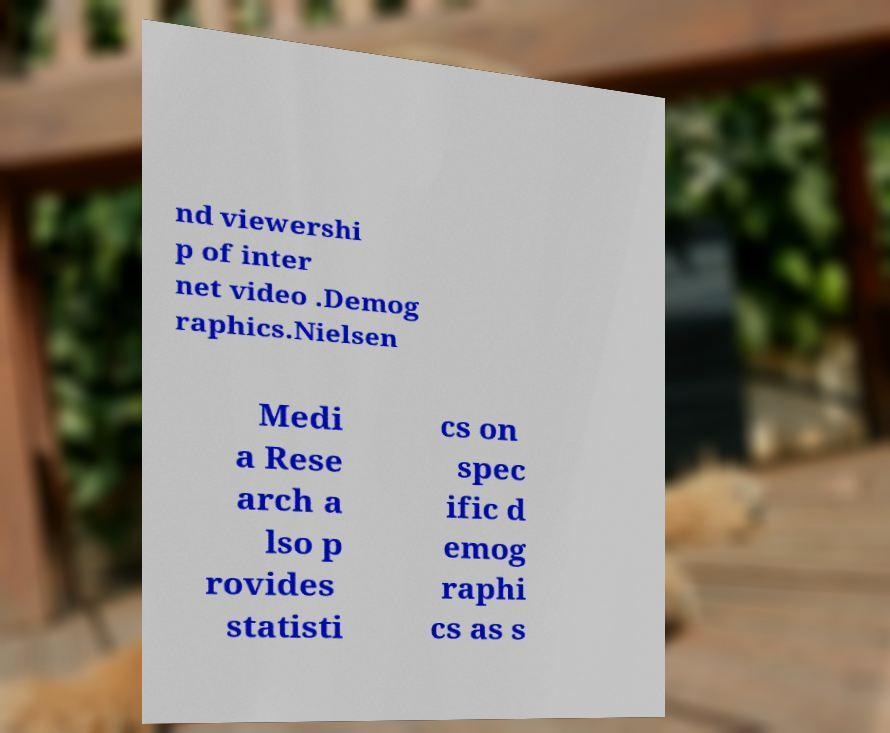Can you read and provide the text displayed in the image?This photo seems to have some interesting text. Can you extract and type it out for me? nd viewershi p of inter net video .Demog raphics.Nielsen Medi a Rese arch a lso p rovides statisti cs on spec ific d emog raphi cs as s 